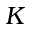<formula> <loc_0><loc_0><loc_500><loc_500>K</formula> 